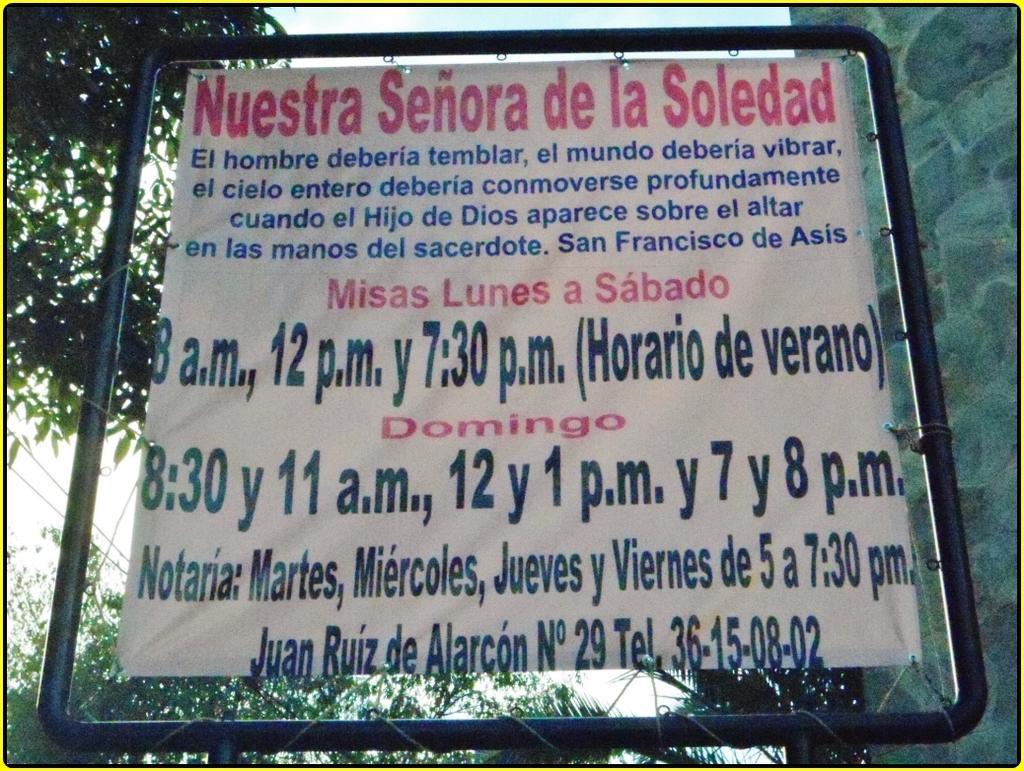How would you summarize this image in a sentence or two? In the center of the image we can see banner. On the right side of the image we can see wall. In the background we can see trees and sky. 